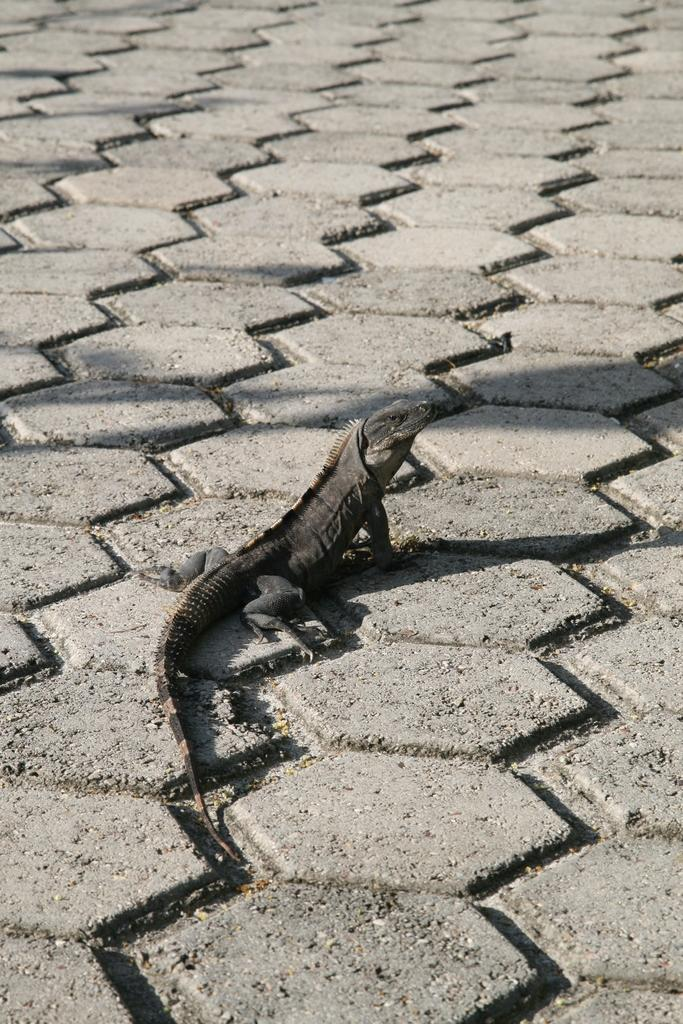What type of animal is present on the surface in the image? There is a reptile on the surface in the image. What type of cream is being used to sing songs in the image? There is no cream or singing in the image; it features a reptile on a surface. 